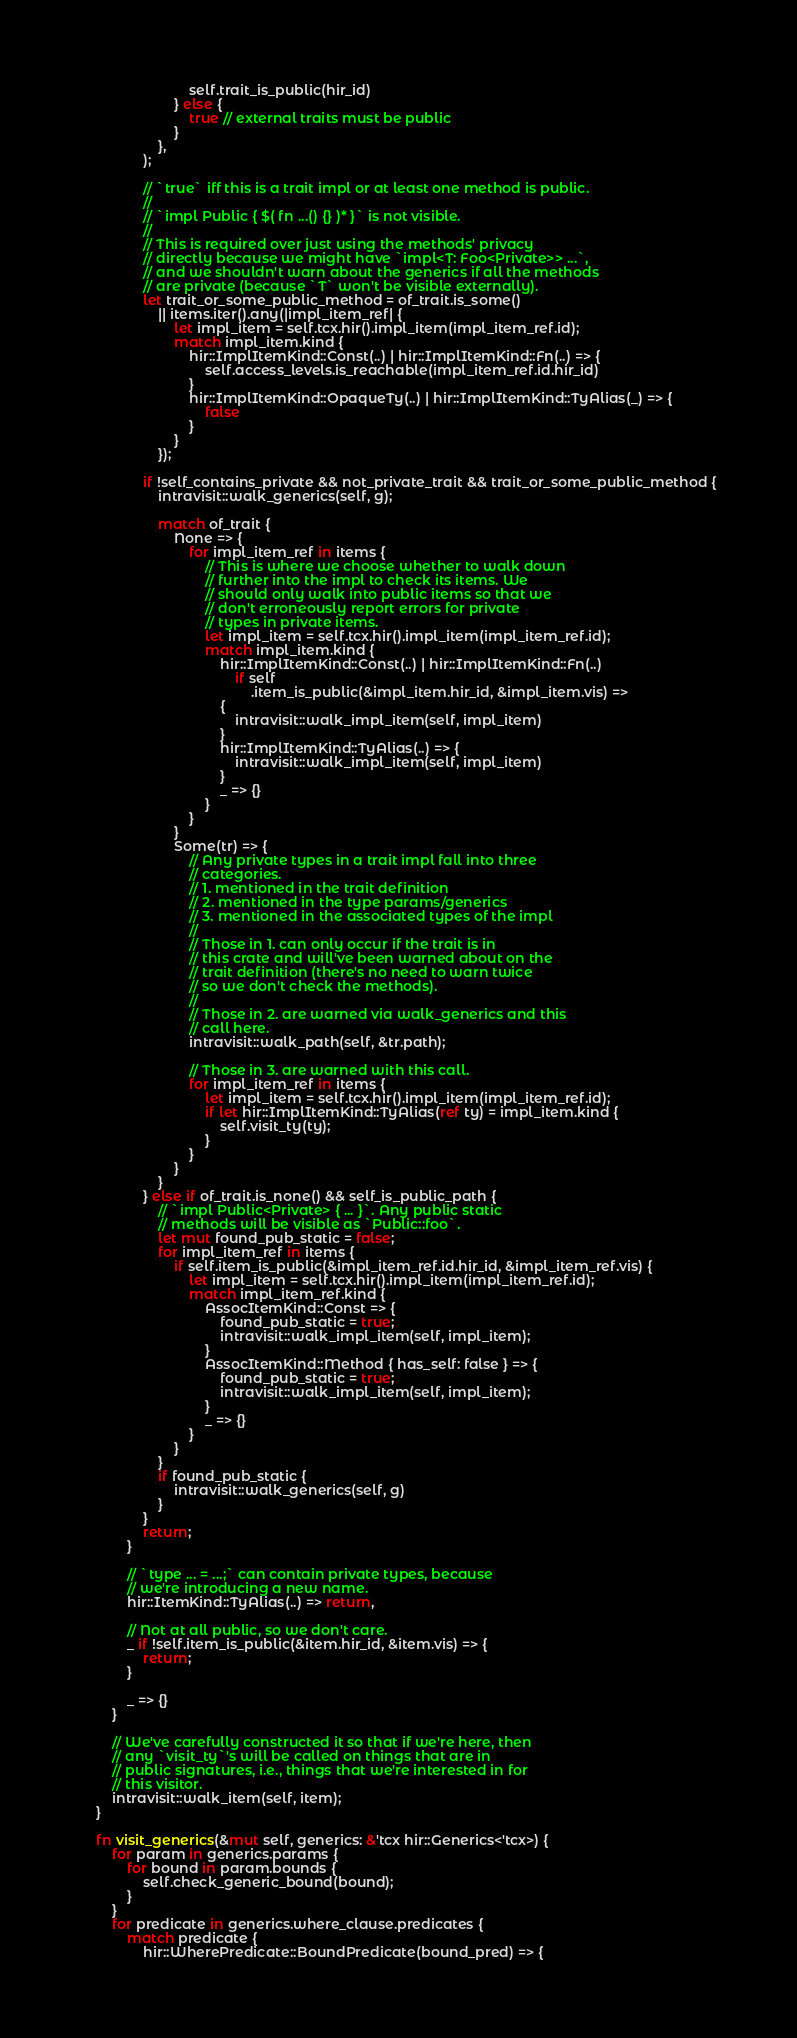<code> <loc_0><loc_0><loc_500><loc_500><_Rust_>                            self.trait_is_public(hir_id)
                        } else {
                            true // external traits must be public
                        }
                    },
                );

                // `true` iff this is a trait impl or at least one method is public.
                //
                // `impl Public { $( fn ...() {} )* }` is not visible.
                //
                // This is required over just using the methods' privacy
                // directly because we might have `impl<T: Foo<Private>> ...`,
                // and we shouldn't warn about the generics if all the methods
                // are private (because `T` won't be visible externally).
                let trait_or_some_public_method = of_trait.is_some()
                    || items.iter().any(|impl_item_ref| {
                        let impl_item = self.tcx.hir().impl_item(impl_item_ref.id);
                        match impl_item.kind {
                            hir::ImplItemKind::Const(..) | hir::ImplItemKind::Fn(..) => {
                                self.access_levels.is_reachable(impl_item_ref.id.hir_id)
                            }
                            hir::ImplItemKind::OpaqueTy(..) | hir::ImplItemKind::TyAlias(_) => {
                                false
                            }
                        }
                    });

                if !self_contains_private && not_private_trait && trait_or_some_public_method {
                    intravisit::walk_generics(self, g);

                    match of_trait {
                        None => {
                            for impl_item_ref in items {
                                // This is where we choose whether to walk down
                                // further into the impl to check its items. We
                                // should only walk into public items so that we
                                // don't erroneously report errors for private
                                // types in private items.
                                let impl_item = self.tcx.hir().impl_item(impl_item_ref.id);
                                match impl_item.kind {
                                    hir::ImplItemKind::Const(..) | hir::ImplItemKind::Fn(..)
                                        if self
                                            .item_is_public(&impl_item.hir_id, &impl_item.vis) =>
                                    {
                                        intravisit::walk_impl_item(self, impl_item)
                                    }
                                    hir::ImplItemKind::TyAlias(..) => {
                                        intravisit::walk_impl_item(self, impl_item)
                                    }
                                    _ => {}
                                }
                            }
                        }
                        Some(tr) => {
                            // Any private types in a trait impl fall into three
                            // categories.
                            // 1. mentioned in the trait definition
                            // 2. mentioned in the type params/generics
                            // 3. mentioned in the associated types of the impl
                            //
                            // Those in 1. can only occur if the trait is in
                            // this crate and will've been warned about on the
                            // trait definition (there's no need to warn twice
                            // so we don't check the methods).
                            //
                            // Those in 2. are warned via walk_generics and this
                            // call here.
                            intravisit::walk_path(self, &tr.path);

                            // Those in 3. are warned with this call.
                            for impl_item_ref in items {
                                let impl_item = self.tcx.hir().impl_item(impl_item_ref.id);
                                if let hir::ImplItemKind::TyAlias(ref ty) = impl_item.kind {
                                    self.visit_ty(ty);
                                }
                            }
                        }
                    }
                } else if of_trait.is_none() && self_is_public_path {
                    // `impl Public<Private> { ... }`. Any public static
                    // methods will be visible as `Public::foo`.
                    let mut found_pub_static = false;
                    for impl_item_ref in items {
                        if self.item_is_public(&impl_item_ref.id.hir_id, &impl_item_ref.vis) {
                            let impl_item = self.tcx.hir().impl_item(impl_item_ref.id);
                            match impl_item_ref.kind {
                                AssocItemKind::Const => {
                                    found_pub_static = true;
                                    intravisit::walk_impl_item(self, impl_item);
                                }
                                AssocItemKind::Method { has_self: false } => {
                                    found_pub_static = true;
                                    intravisit::walk_impl_item(self, impl_item);
                                }
                                _ => {}
                            }
                        }
                    }
                    if found_pub_static {
                        intravisit::walk_generics(self, g)
                    }
                }
                return;
            }

            // `type ... = ...;` can contain private types, because
            // we're introducing a new name.
            hir::ItemKind::TyAlias(..) => return,

            // Not at all public, so we don't care.
            _ if !self.item_is_public(&item.hir_id, &item.vis) => {
                return;
            }

            _ => {}
        }

        // We've carefully constructed it so that if we're here, then
        // any `visit_ty`'s will be called on things that are in
        // public signatures, i.e., things that we're interested in for
        // this visitor.
        intravisit::walk_item(self, item);
    }

    fn visit_generics(&mut self, generics: &'tcx hir::Generics<'tcx>) {
        for param in generics.params {
            for bound in param.bounds {
                self.check_generic_bound(bound);
            }
        }
        for predicate in generics.where_clause.predicates {
            match predicate {
                hir::WherePredicate::BoundPredicate(bound_pred) => {</code> 